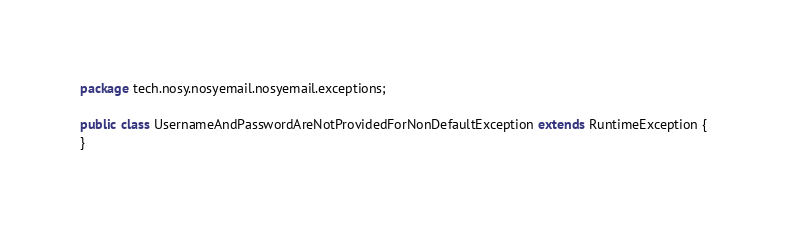Convert code to text. <code><loc_0><loc_0><loc_500><loc_500><_Java_>package tech.nosy.nosyemail.nosyemail.exceptions;

public class UsernameAndPasswordAreNotProvidedForNonDefaultException extends RuntimeException {
}
</code> 